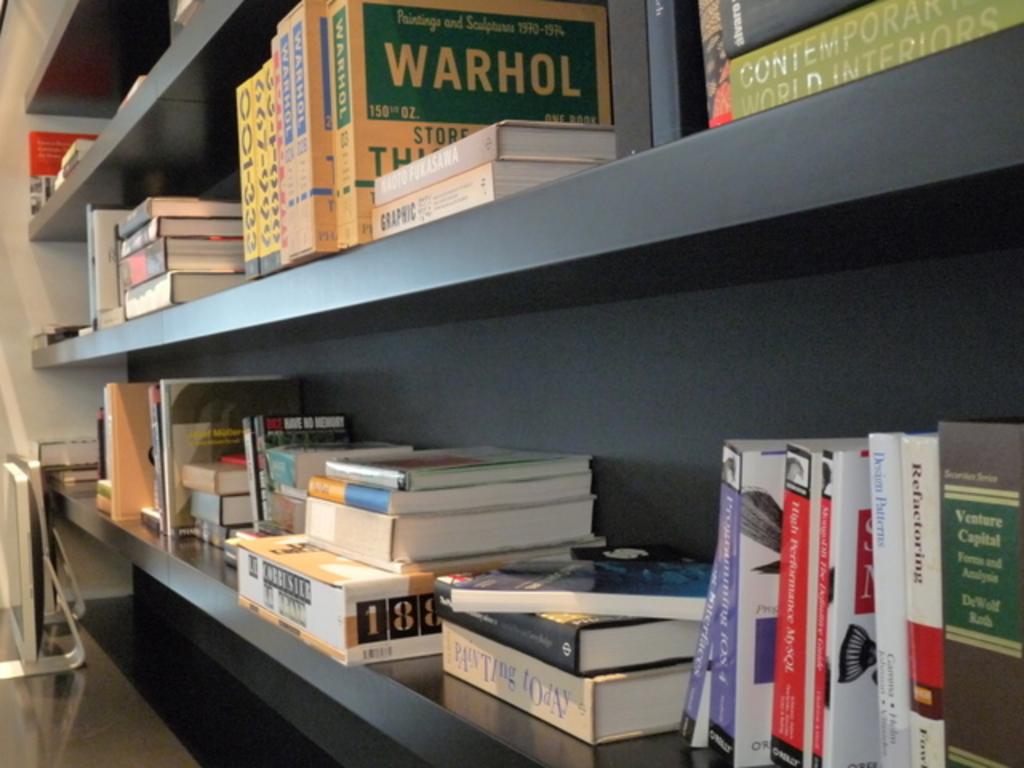Is there a book on warhol?
Make the answer very short. Yes. 